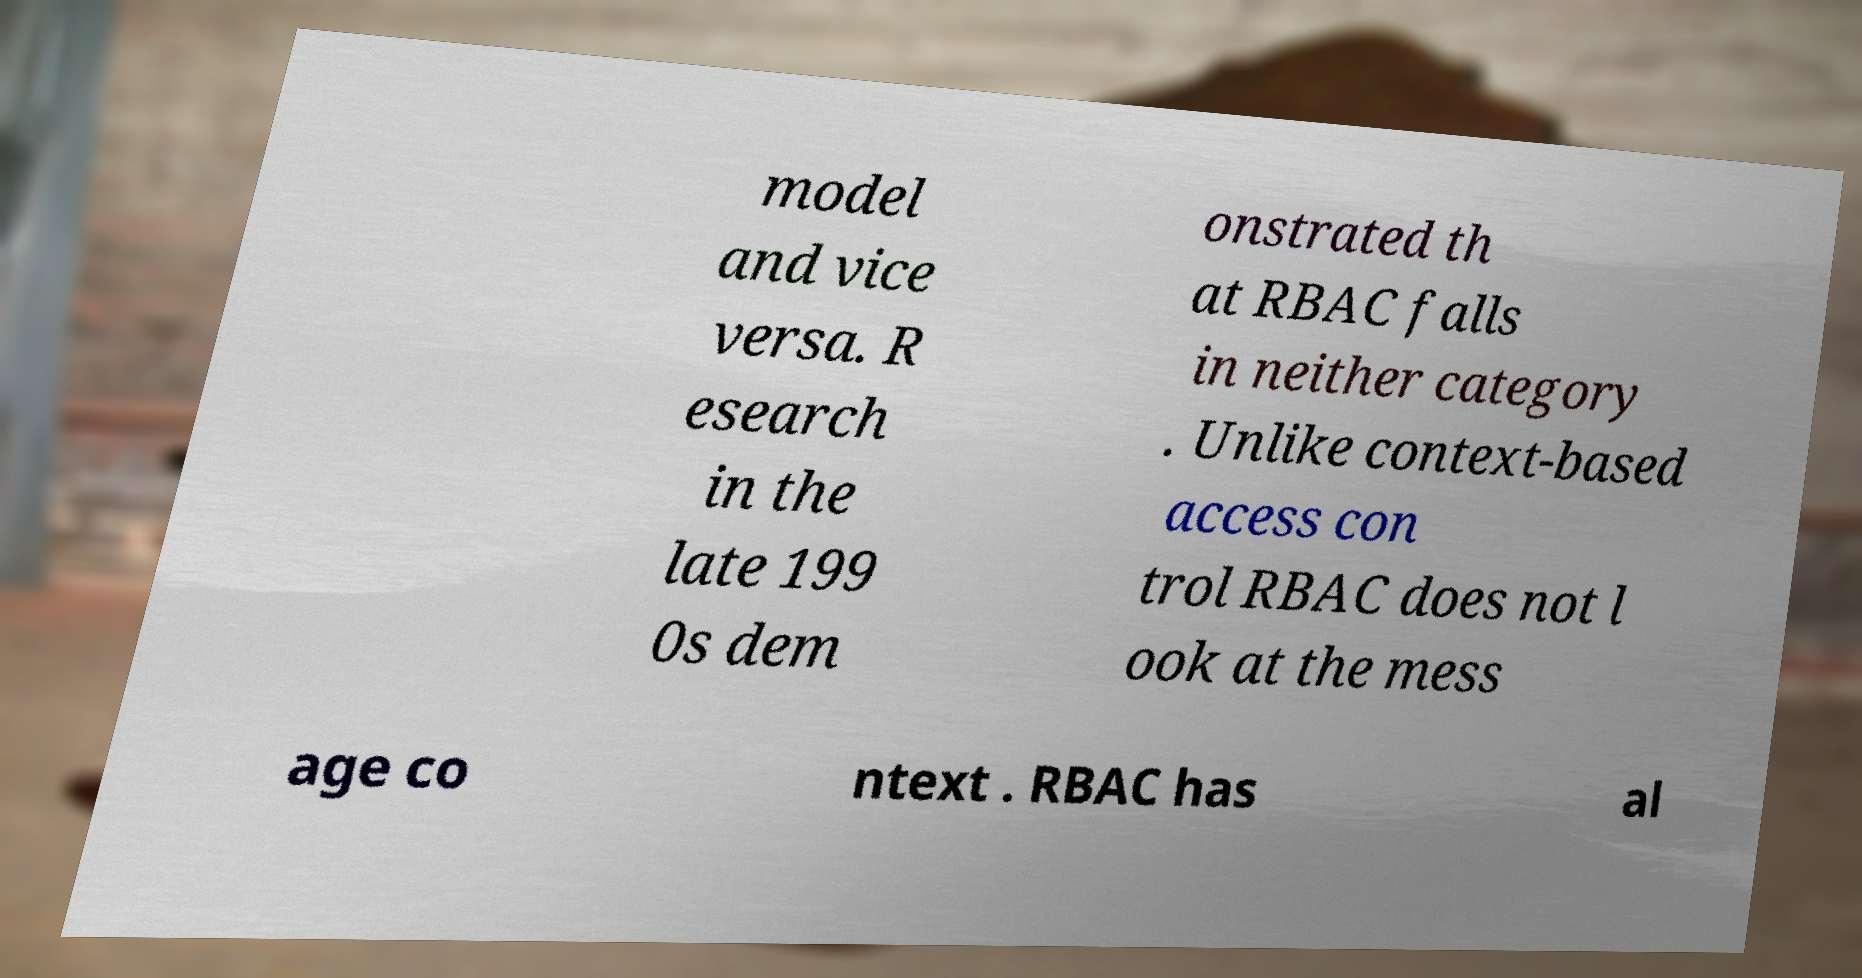Could you extract and type out the text from this image? model and vice versa. R esearch in the late 199 0s dem onstrated th at RBAC falls in neither category . Unlike context-based access con trol RBAC does not l ook at the mess age co ntext . RBAC has al 